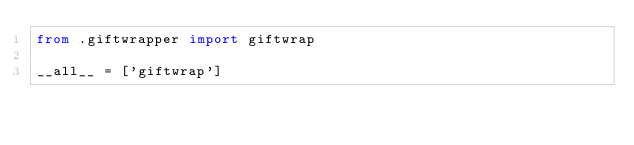Convert code to text. <code><loc_0><loc_0><loc_500><loc_500><_Python_>from .giftwrapper import giftwrap

__all__ = ['giftwrap']
</code> 